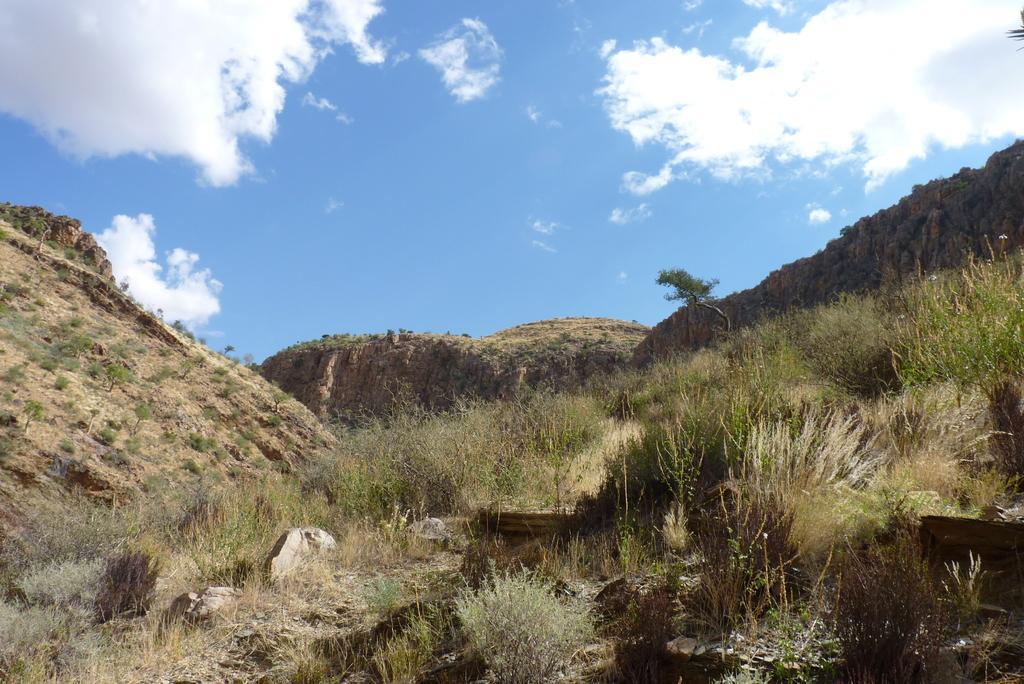Can you describe this image briefly? In the picture we can see two hills between we can see some grass plants and behind we can see another hill with some plants on it and in the background we can see a sky with clouds. 